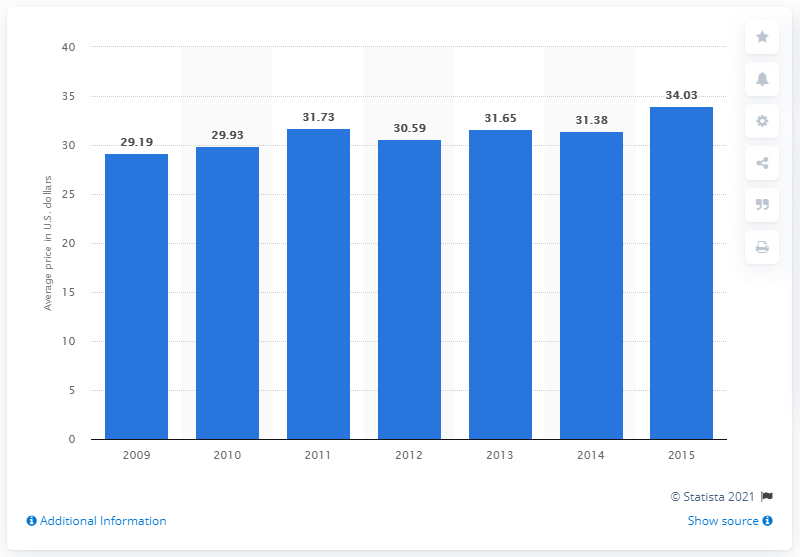Give some essential details in this illustration. In 2010, the average price of gel fills in the United States increased. In 2009, the average price of gel fills in the United States was 29.19. In 2015, the average price of gel fills in the United States was 34.03 dollars. 